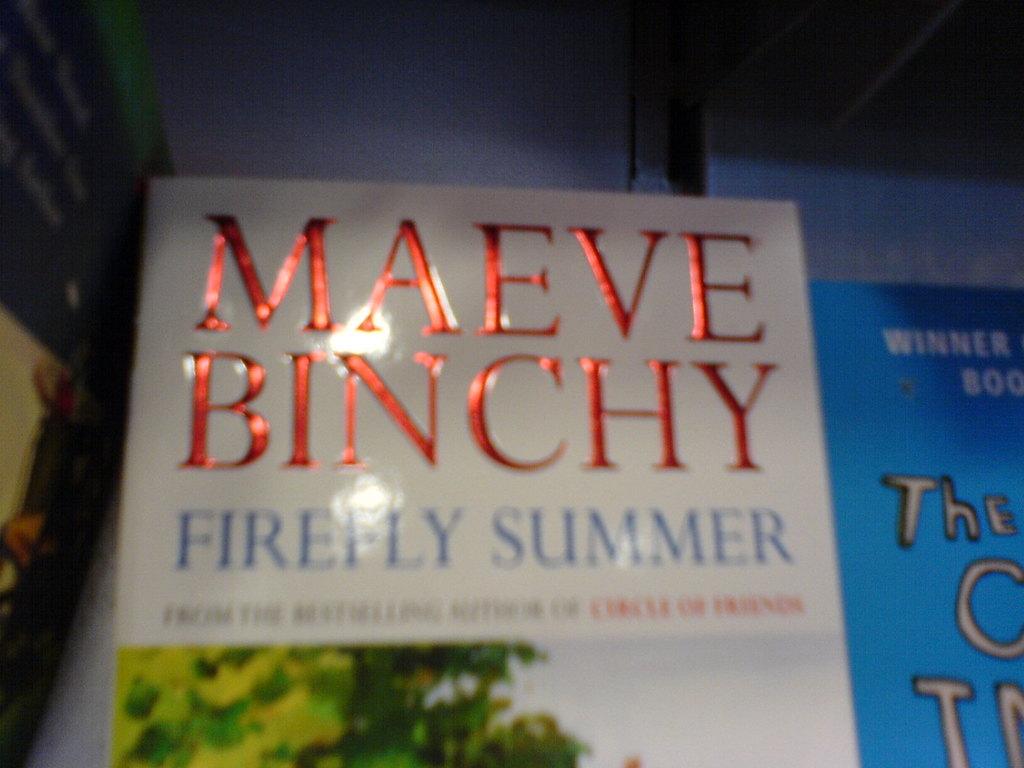Who is the author of this book?
Offer a terse response. Maeve binchy. 